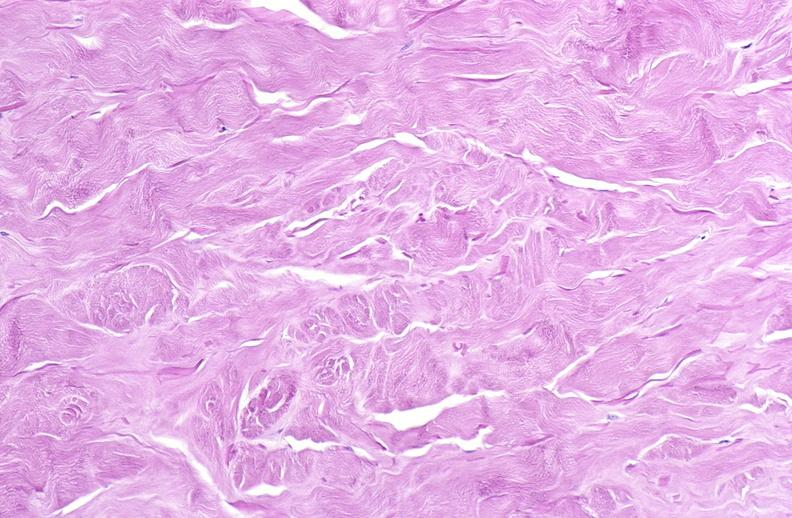does this image show scleroderma?
Answer the question using a single word or phrase. Yes 